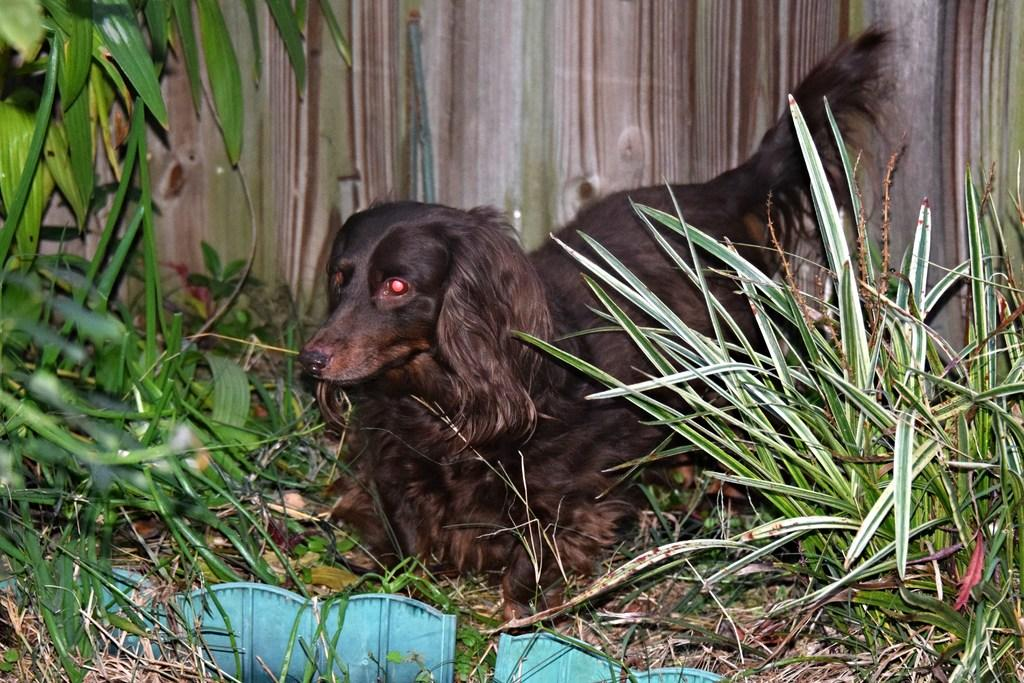What animal can be seen in the image? There is a dog in the image. Where is the dog positioned in relation to the fence? The dog is standing in front of a fence. What type of vegetation is present on either side of the fence? There are plants on either side of the fence. Are the plants growing on the ground or in the air? The plants are on the land. What type of mint can be seen growing on the dog's flesh in the image? There is no mint or flesh visible in the image, and the dog is not shown with any plants growing on its body. 